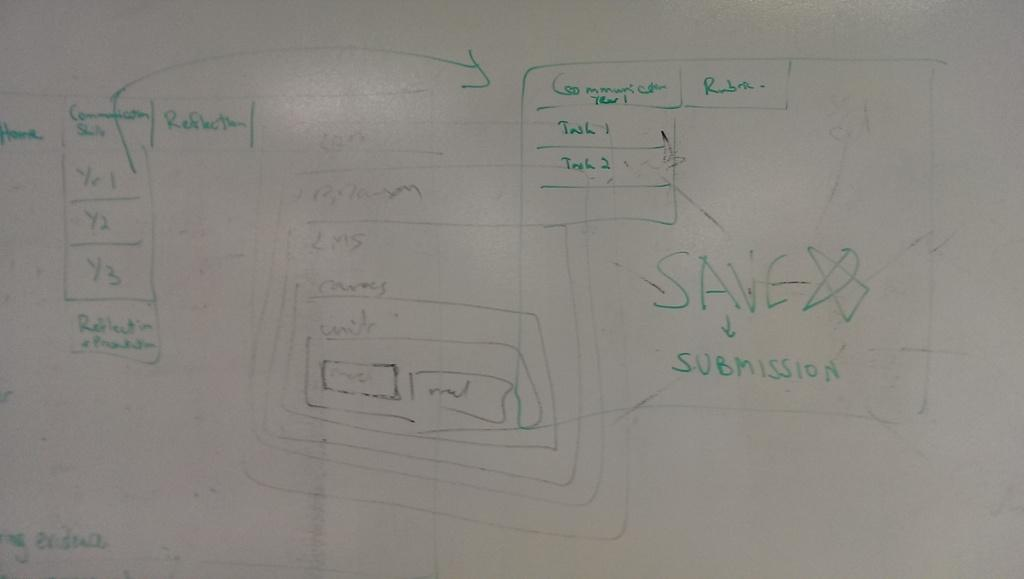<image>
Render a clear and concise summary of the photo. A white board with green writing includes the word reflection. 